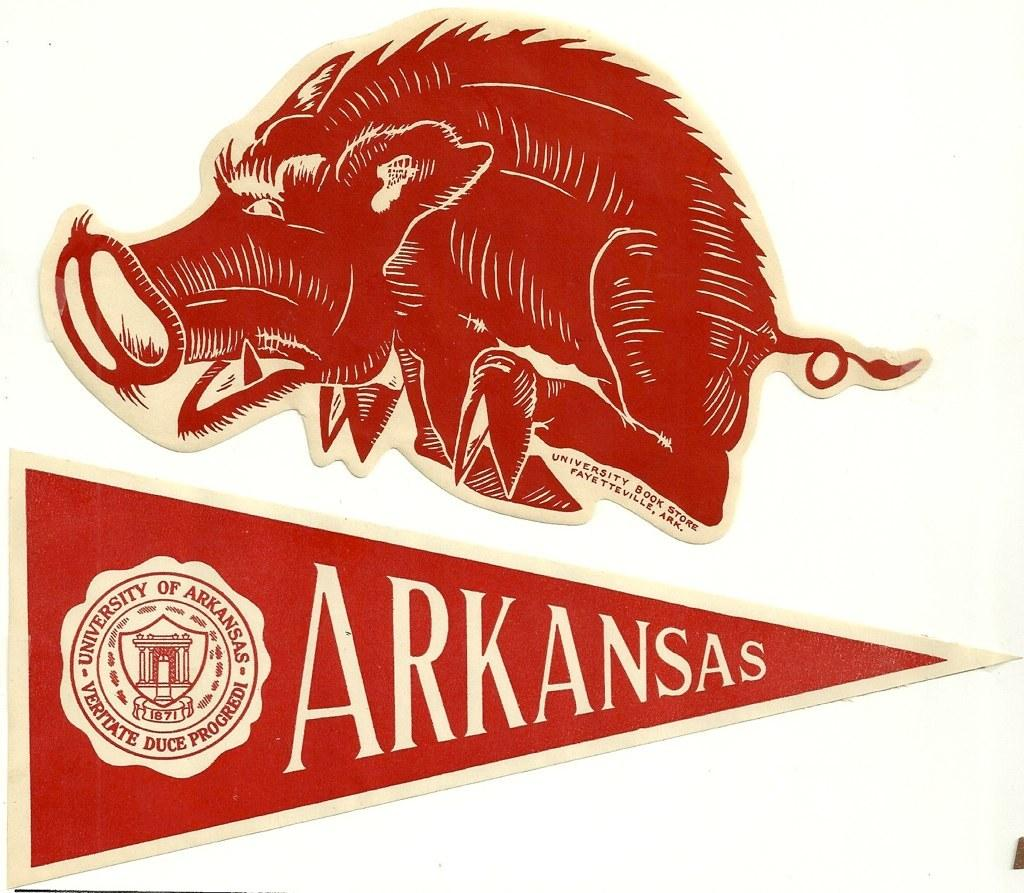What can be found in the image that represents a company or organization? There are logos in the image that represent companies or organizations. What else is present in the image besides logos? There is text in the image. What color is the background of the image? The background of the image is white. What type of lettuce is being used as a prop in the image? There is no lettuce present in the image. Is there a band performing in the image? There is no band or any indication of a performance in the image. 